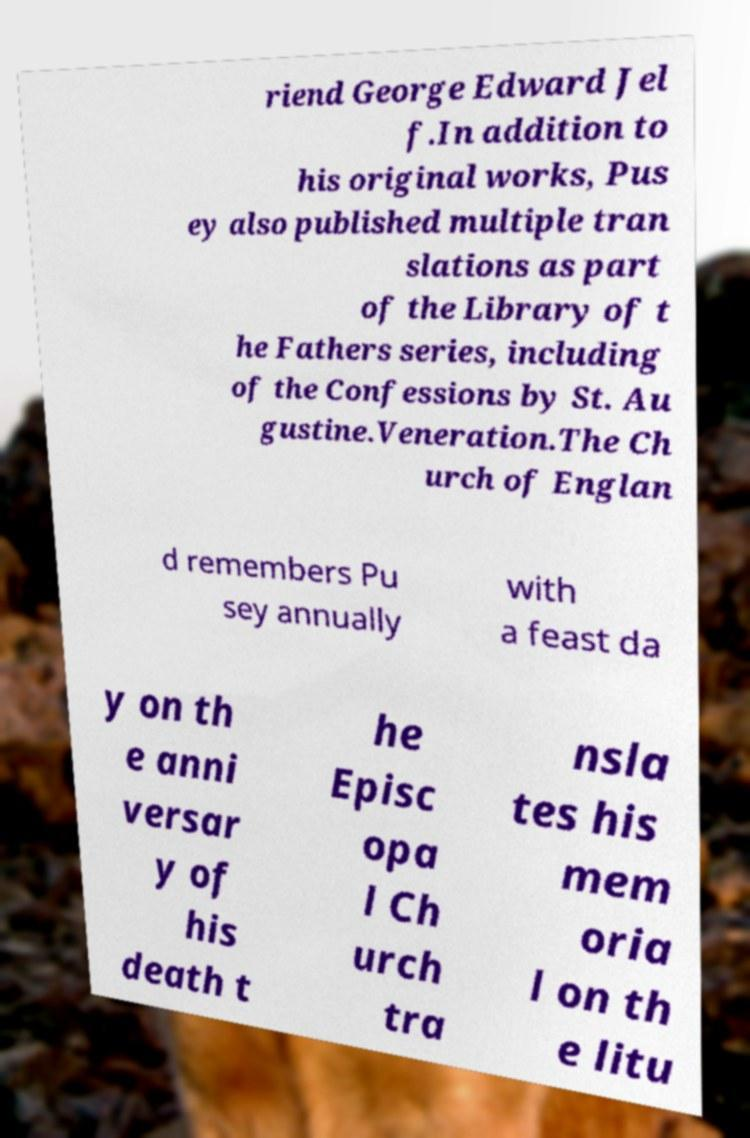I need the written content from this picture converted into text. Can you do that? riend George Edward Jel f.In addition to his original works, Pus ey also published multiple tran slations as part of the Library of t he Fathers series, including of the Confessions by St. Au gustine.Veneration.The Ch urch of Englan d remembers Pu sey annually with a feast da y on th e anni versar y of his death t he Episc opa l Ch urch tra nsla tes his mem oria l on th e litu 